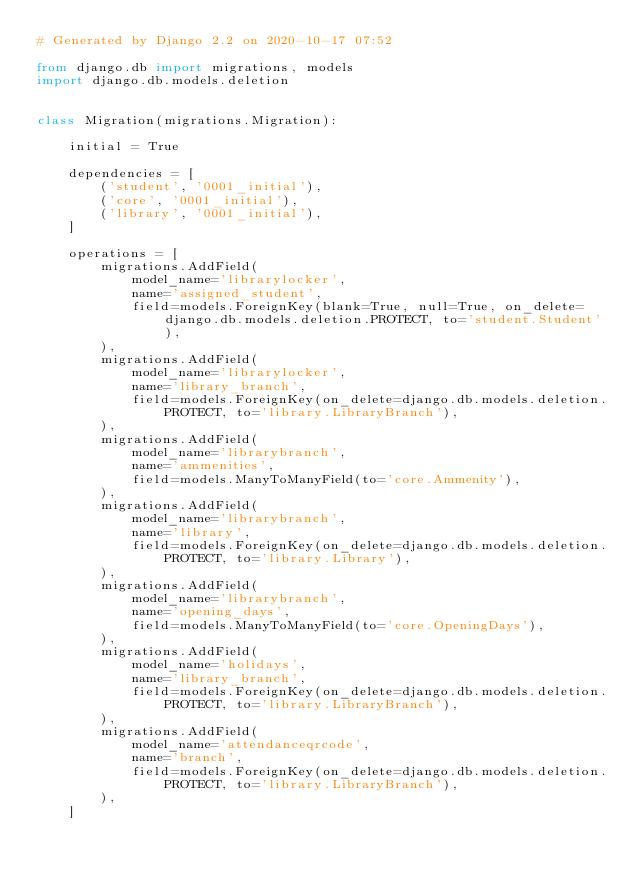<code> <loc_0><loc_0><loc_500><loc_500><_Python_># Generated by Django 2.2 on 2020-10-17 07:52

from django.db import migrations, models
import django.db.models.deletion


class Migration(migrations.Migration):

    initial = True

    dependencies = [
        ('student', '0001_initial'),
        ('core', '0001_initial'),
        ('library', '0001_initial'),
    ]

    operations = [
        migrations.AddField(
            model_name='librarylocker',
            name='assigned_student',
            field=models.ForeignKey(blank=True, null=True, on_delete=django.db.models.deletion.PROTECT, to='student.Student'),
        ),
        migrations.AddField(
            model_name='librarylocker',
            name='library_branch',
            field=models.ForeignKey(on_delete=django.db.models.deletion.PROTECT, to='library.LibraryBranch'),
        ),
        migrations.AddField(
            model_name='librarybranch',
            name='ammenities',
            field=models.ManyToManyField(to='core.Ammenity'),
        ),
        migrations.AddField(
            model_name='librarybranch',
            name='library',
            field=models.ForeignKey(on_delete=django.db.models.deletion.PROTECT, to='library.Library'),
        ),
        migrations.AddField(
            model_name='librarybranch',
            name='opening_days',
            field=models.ManyToManyField(to='core.OpeningDays'),
        ),
        migrations.AddField(
            model_name='holidays',
            name='library_branch',
            field=models.ForeignKey(on_delete=django.db.models.deletion.PROTECT, to='library.LibraryBranch'),
        ),
        migrations.AddField(
            model_name='attendanceqrcode',
            name='branch',
            field=models.ForeignKey(on_delete=django.db.models.deletion.PROTECT, to='library.LibraryBranch'),
        ),
    ]
</code> 